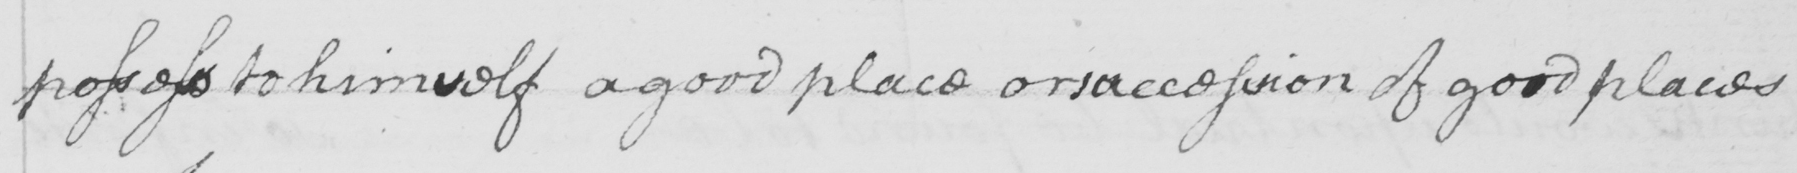Please transcribe the handwritten text in this image. possess to himself a good place or succession of good places 